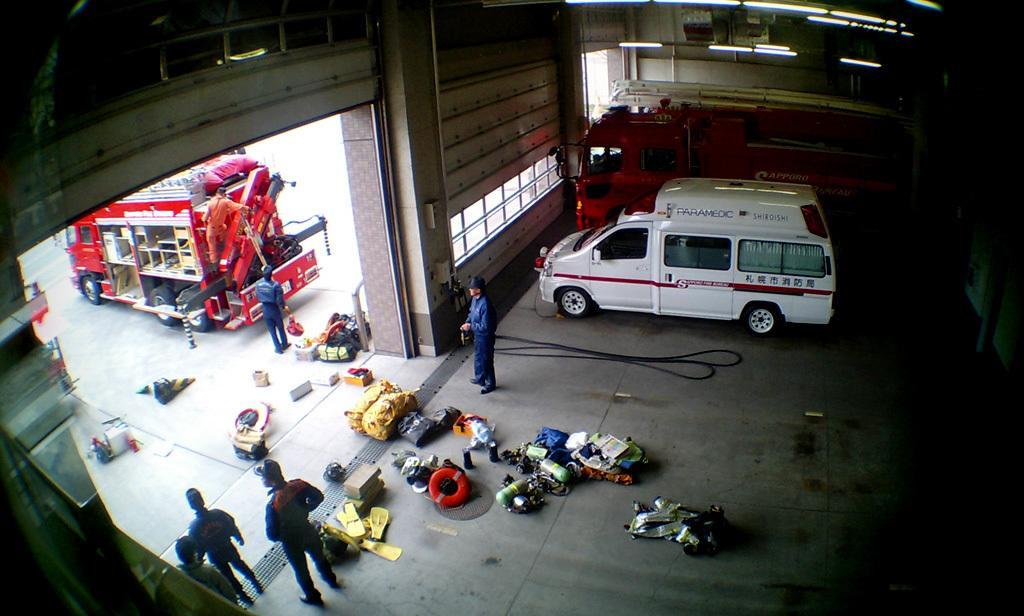How would you summarize this image in a sentence or two? In the picture we can see inside the shed with fire engine vehicle and some other vehicle beside it and beside it we can see some people are standing and some things are placed on the floor and outside the shed we can see a fire engine vehicle and one person standing on it and one person standing behind it and we can also see some things are placed on the path. 